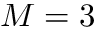<formula> <loc_0><loc_0><loc_500><loc_500>M = 3</formula> 